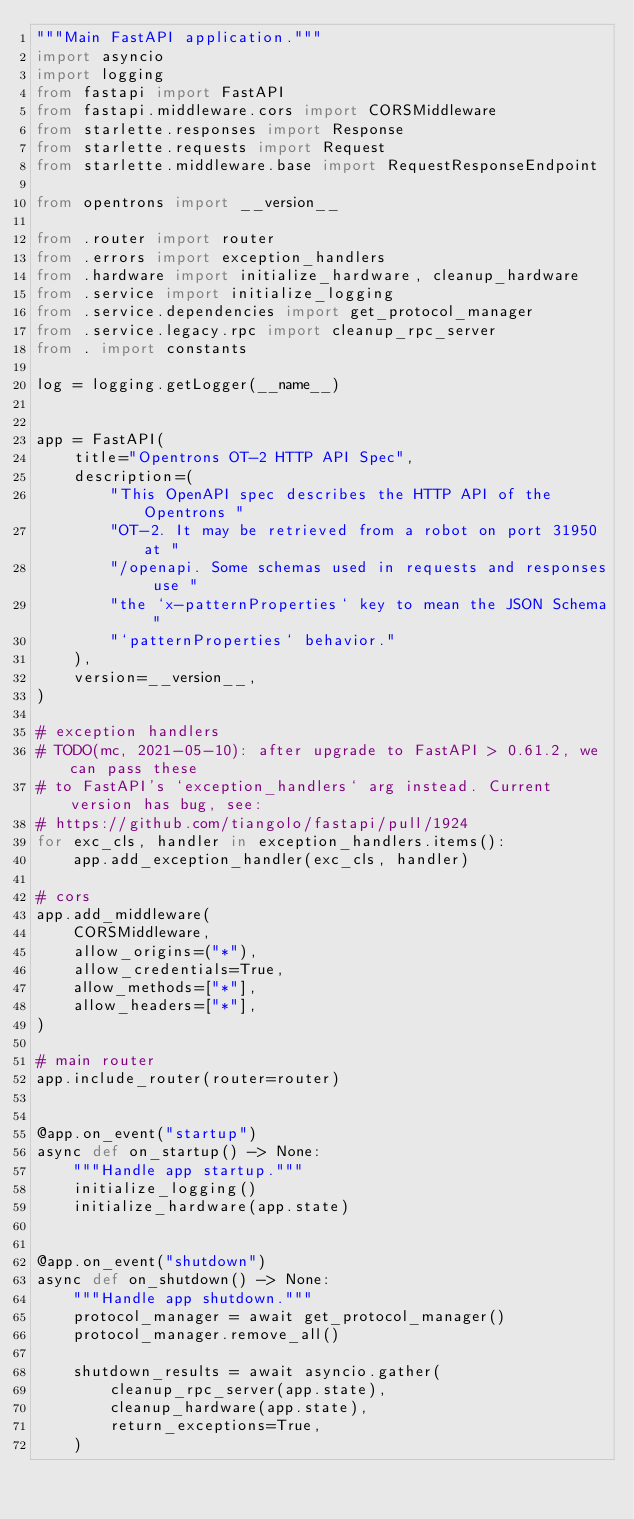Convert code to text. <code><loc_0><loc_0><loc_500><loc_500><_Python_>"""Main FastAPI application."""
import asyncio
import logging
from fastapi import FastAPI
from fastapi.middleware.cors import CORSMiddleware
from starlette.responses import Response
from starlette.requests import Request
from starlette.middleware.base import RequestResponseEndpoint

from opentrons import __version__

from .router import router
from .errors import exception_handlers
from .hardware import initialize_hardware, cleanup_hardware
from .service import initialize_logging
from .service.dependencies import get_protocol_manager
from .service.legacy.rpc import cleanup_rpc_server
from . import constants

log = logging.getLogger(__name__)


app = FastAPI(
    title="Opentrons OT-2 HTTP API Spec",
    description=(
        "This OpenAPI spec describes the HTTP API of the Opentrons "
        "OT-2. It may be retrieved from a robot on port 31950 at "
        "/openapi. Some schemas used in requests and responses use "
        "the `x-patternProperties` key to mean the JSON Schema "
        "`patternProperties` behavior."
    ),
    version=__version__,
)

# exception handlers
# TODO(mc, 2021-05-10): after upgrade to FastAPI > 0.61.2, we can pass these
# to FastAPI's `exception_handlers` arg instead. Current version has bug, see:
# https://github.com/tiangolo/fastapi/pull/1924
for exc_cls, handler in exception_handlers.items():
    app.add_exception_handler(exc_cls, handler)

# cors
app.add_middleware(
    CORSMiddleware,
    allow_origins=("*"),
    allow_credentials=True,
    allow_methods=["*"],
    allow_headers=["*"],
)

# main router
app.include_router(router=router)


@app.on_event("startup")
async def on_startup() -> None:
    """Handle app startup."""
    initialize_logging()
    initialize_hardware(app.state)


@app.on_event("shutdown")
async def on_shutdown() -> None:
    """Handle app shutdown."""
    protocol_manager = await get_protocol_manager()
    protocol_manager.remove_all()

    shutdown_results = await asyncio.gather(
        cleanup_rpc_server(app.state),
        cleanup_hardware(app.state),
        return_exceptions=True,
    )
</code> 